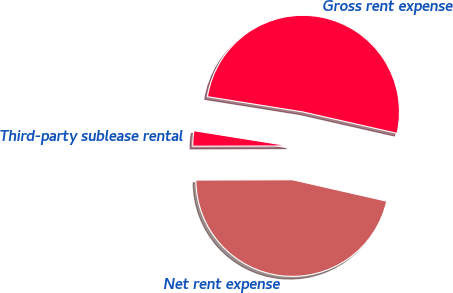Convert chart to OTSL. <chart><loc_0><loc_0><loc_500><loc_500><pie_chart><fcel>Gross rent expense<fcel>Third-party sublease rental<fcel>Net rent expense<nl><fcel>51.03%<fcel>2.57%<fcel>46.39%<nl></chart> 